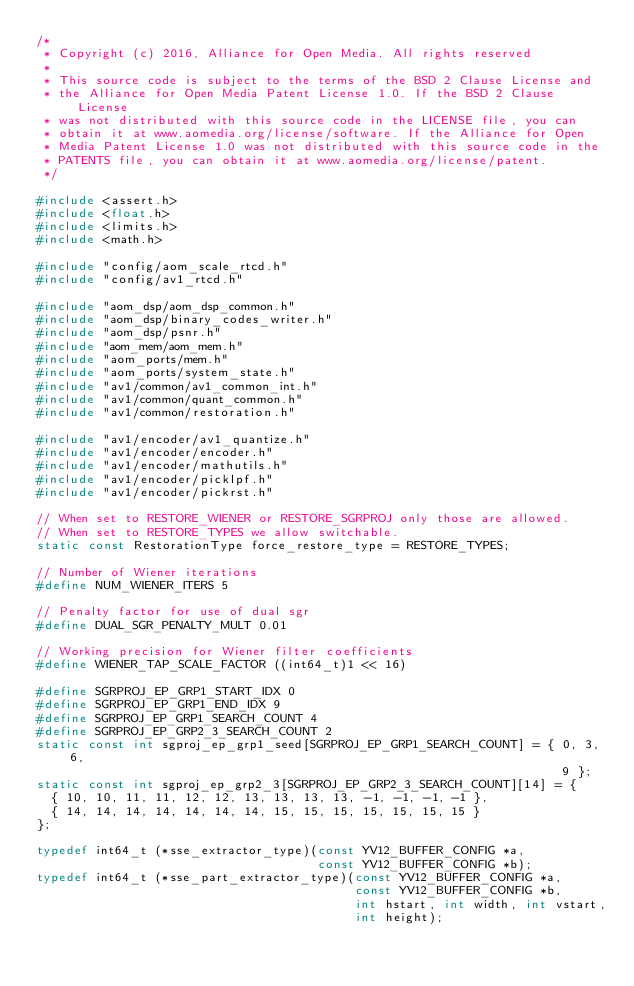<code> <loc_0><loc_0><loc_500><loc_500><_C_>/*
 * Copyright (c) 2016, Alliance for Open Media. All rights reserved
 *
 * This source code is subject to the terms of the BSD 2 Clause License and
 * the Alliance for Open Media Patent License 1.0. If the BSD 2 Clause License
 * was not distributed with this source code in the LICENSE file, you can
 * obtain it at www.aomedia.org/license/software. If the Alliance for Open
 * Media Patent License 1.0 was not distributed with this source code in the
 * PATENTS file, you can obtain it at www.aomedia.org/license/patent.
 */

#include <assert.h>
#include <float.h>
#include <limits.h>
#include <math.h>

#include "config/aom_scale_rtcd.h"
#include "config/av1_rtcd.h"

#include "aom_dsp/aom_dsp_common.h"
#include "aom_dsp/binary_codes_writer.h"
#include "aom_dsp/psnr.h"
#include "aom_mem/aom_mem.h"
#include "aom_ports/mem.h"
#include "aom_ports/system_state.h"
#include "av1/common/av1_common_int.h"
#include "av1/common/quant_common.h"
#include "av1/common/restoration.h"

#include "av1/encoder/av1_quantize.h"
#include "av1/encoder/encoder.h"
#include "av1/encoder/mathutils.h"
#include "av1/encoder/picklpf.h"
#include "av1/encoder/pickrst.h"

// When set to RESTORE_WIENER or RESTORE_SGRPROJ only those are allowed.
// When set to RESTORE_TYPES we allow switchable.
static const RestorationType force_restore_type = RESTORE_TYPES;

// Number of Wiener iterations
#define NUM_WIENER_ITERS 5

// Penalty factor for use of dual sgr
#define DUAL_SGR_PENALTY_MULT 0.01

// Working precision for Wiener filter coefficients
#define WIENER_TAP_SCALE_FACTOR ((int64_t)1 << 16)

#define SGRPROJ_EP_GRP1_START_IDX 0
#define SGRPROJ_EP_GRP1_END_IDX 9
#define SGRPROJ_EP_GRP1_SEARCH_COUNT 4
#define SGRPROJ_EP_GRP2_3_SEARCH_COUNT 2
static const int sgproj_ep_grp1_seed[SGRPROJ_EP_GRP1_SEARCH_COUNT] = { 0, 3, 6,
                                                                       9 };
static const int sgproj_ep_grp2_3[SGRPROJ_EP_GRP2_3_SEARCH_COUNT][14] = {
  { 10, 10, 11, 11, 12, 12, 13, 13, 13, 13, -1, -1, -1, -1 },
  { 14, 14, 14, 14, 14, 14, 14, 15, 15, 15, 15, 15, 15, 15 }
};

typedef int64_t (*sse_extractor_type)(const YV12_BUFFER_CONFIG *a,
                                      const YV12_BUFFER_CONFIG *b);
typedef int64_t (*sse_part_extractor_type)(const YV12_BUFFER_CONFIG *a,
                                           const YV12_BUFFER_CONFIG *b,
                                           int hstart, int width, int vstart,
                                           int height);</code> 